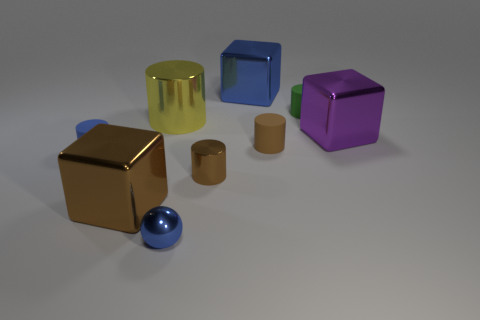There is a yellow cylinder that is the same size as the purple metallic object; what is its material?
Offer a very short reply. Metal. Are there any brown things of the same size as the yellow metal object?
Your answer should be very brief. Yes. There is a big metal block left of the small blue ball; is its color the same as the large metal block behind the tiny green thing?
Your answer should be compact. No. How many metal objects are either big blue cubes or large brown things?
Make the answer very short. 2. There is a shiny block that is in front of the big block that is on the right side of the green rubber object; how many balls are on the left side of it?
Offer a very short reply. 0. What is the size of the brown object that is made of the same material as the blue cylinder?
Offer a very short reply. Small. How many other spheres have the same color as the tiny ball?
Your answer should be very brief. 0. There is a metal block in front of the blue rubber object; does it have the same size as the big purple object?
Keep it short and to the point. Yes. There is a metallic cube that is both to the right of the tiny blue metal thing and in front of the large blue thing; what is its color?
Make the answer very short. Purple. What number of objects are either large brown shiny cubes or small things in front of the big brown shiny object?
Give a very brief answer. 2. 